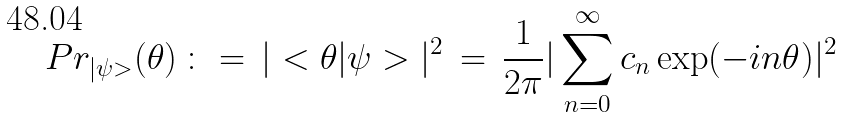Convert formula to latex. <formula><loc_0><loc_0><loc_500><loc_500>P r _ { | \psi > } ( \theta ) \, \colon = \, | < \theta | \psi > | ^ { 2 } \, = \, \frac { 1 } { 2 \pi } | \sum _ { n = 0 } ^ { \infty } c _ { n } \exp ( - i n \theta ) | ^ { 2 }</formula> 